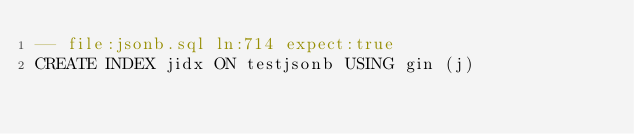Convert code to text. <code><loc_0><loc_0><loc_500><loc_500><_SQL_>-- file:jsonb.sql ln:714 expect:true
CREATE INDEX jidx ON testjsonb USING gin (j)
</code> 